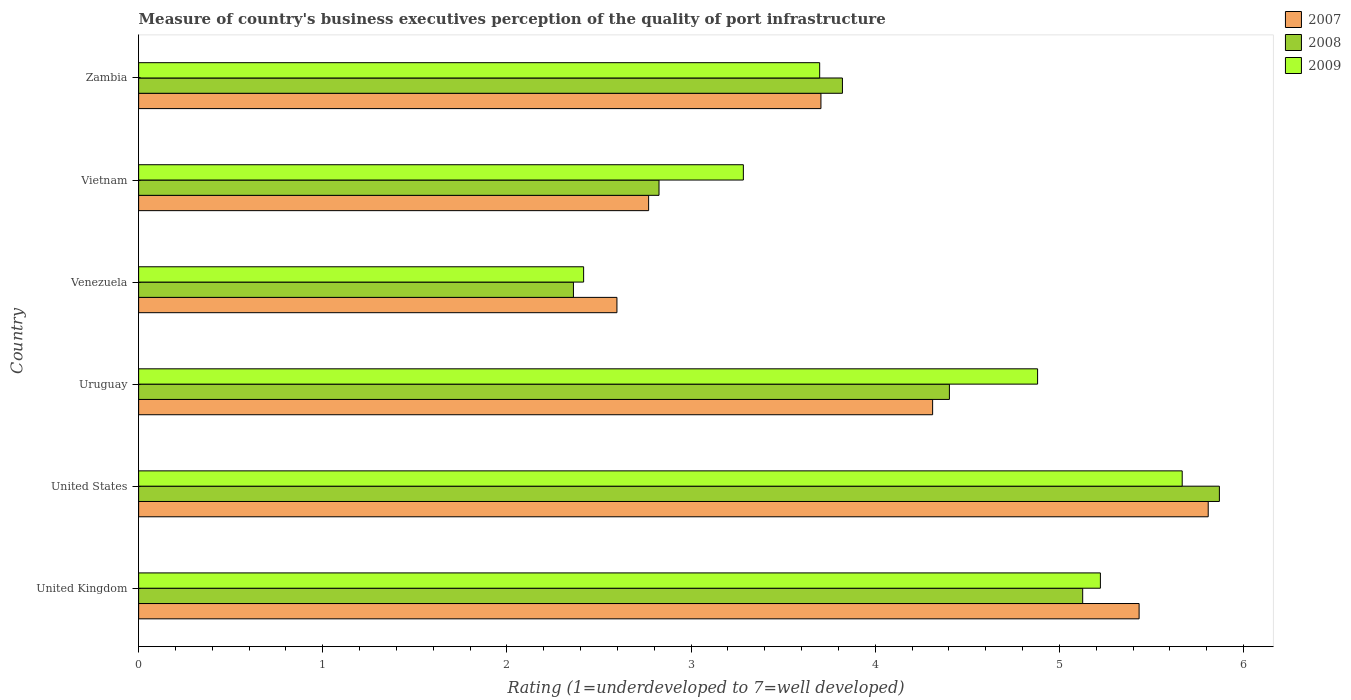How many different coloured bars are there?
Ensure brevity in your answer.  3. How many groups of bars are there?
Give a very brief answer. 6. Are the number of bars on each tick of the Y-axis equal?
Keep it short and to the point. Yes. How many bars are there on the 3rd tick from the top?
Provide a short and direct response. 3. What is the label of the 1st group of bars from the top?
Make the answer very short. Zambia. What is the ratings of the quality of port infrastructure in 2009 in Venezuela?
Offer a very short reply. 2.42. Across all countries, what is the maximum ratings of the quality of port infrastructure in 2008?
Provide a short and direct response. 5.87. Across all countries, what is the minimum ratings of the quality of port infrastructure in 2007?
Keep it short and to the point. 2.6. In which country was the ratings of the quality of port infrastructure in 2008 minimum?
Give a very brief answer. Venezuela. What is the total ratings of the quality of port infrastructure in 2007 in the graph?
Your answer should be compact. 24.62. What is the difference between the ratings of the quality of port infrastructure in 2007 in United States and that in Vietnam?
Offer a terse response. 3.04. What is the difference between the ratings of the quality of port infrastructure in 2007 in Vietnam and the ratings of the quality of port infrastructure in 2008 in United States?
Keep it short and to the point. -3.1. What is the average ratings of the quality of port infrastructure in 2008 per country?
Your answer should be compact. 4.07. What is the difference between the ratings of the quality of port infrastructure in 2008 and ratings of the quality of port infrastructure in 2007 in Zambia?
Your answer should be very brief. 0.12. In how many countries, is the ratings of the quality of port infrastructure in 2009 greater than 3.6 ?
Provide a succinct answer. 4. What is the ratio of the ratings of the quality of port infrastructure in 2009 in United Kingdom to that in Vietnam?
Your answer should be very brief. 1.59. Is the difference between the ratings of the quality of port infrastructure in 2008 in United Kingdom and United States greater than the difference between the ratings of the quality of port infrastructure in 2007 in United Kingdom and United States?
Offer a terse response. No. What is the difference between the highest and the second highest ratings of the quality of port infrastructure in 2008?
Your answer should be compact. 0.74. What is the difference between the highest and the lowest ratings of the quality of port infrastructure in 2008?
Your answer should be compact. 3.51. In how many countries, is the ratings of the quality of port infrastructure in 2008 greater than the average ratings of the quality of port infrastructure in 2008 taken over all countries?
Keep it short and to the point. 3. How many bars are there?
Make the answer very short. 18. Are all the bars in the graph horizontal?
Keep it short and to the point. Yes. Are the values on the major ticks of X-axis written in scientific E-notation?
Offer a very short reply. No. Does the graph contain any zero values?
Make the answer very short. No. Where does the legend appear in the graph?
Offer a very short reply. Top right. What is the title of the graph?
Provide a succinct answer. Measure of country's business executives perception of the quality of port infrastructure. Does "1961" appear as one of the legend labels in the graph?
Your answer should be very brief. No. What is the label or title of the X-axis?
Make the answer very short. Rating (1=underdeveloped to 7=well developed). What is the label or title of the Y-axis?
Give a very brief answer. Country. What is the Rating (1=underdeveloped to 7=well developed) in 2007 in United Kingdom?
Your answer should be very brief. 5.43. What is the Rating (1=underdeveloped to 7=well developed) of 2008 in United Kingdom?
Make the answer very short. 5.13. What is the Rating (1=underdeveloped to 7=well developed) of 2009 in United Kingdom?
Ensure brevity in your answer.  5.22. What is the Rating (1=underdeveloped to 7=well developed) in 2007 in United States?
Keep it short and to the point. 5.81. What is the Rating (1=underdeveloped to 7=well developed) of 2008 in United States?
Your response must be concise. 5.87. What is the Rating (1=underdeveloped to 7=well developed) in 2009 in United States?
Ensure brevity in your answer.  5.67. What is the Rating (1=underdeveloped to 7=well developed) in 2007 in Uruguay?
Your answer should be compact. 4.31. What is the Rating (1=underdeveloped to 7=well developed) of 2008 in Uruguay?
Provide a short and direct response. 4.4. What is the Rating (1=underdeveloped to 7=well developed) in 2009 in Uruguay?
Keep it short and to the point. 4.88. What is the Rating (1=underdeveloped to 7=well developed) of 2007 in Venezuela?
Offer a very short reply. 2.6. What is the Rating (1=underdeveloped to 7=well developed) of 2008 in Venezuela?
Ensure brevity in your answer.  2.36. What is the Rating (1=underdeveloped to 7=well developed) in 2009 in Venezuela?
Give a very brief answer. 2.42. What is the Rating (1=underdeveloped to 7=well developed) of 2007 in Vietnam?
Offer a very short reply. 2.77. What is the Rating (1=underdeveloped to 7=well developed) of 2008 in Vietnam?
Keep it short and to the point. 2.83. What is the Rating (1=underdeveloped to 7=well developed) in 2009 in Vietnam?
Provide a short and direct response. 3.28. What is the Rating (1=underdeveloped to 7=well developed) in 2007 in Zambia?
Keep it short and to the point. 3.7. What is the Rating (1=underdeveloped to 7=well developed) in 2008 in Zambia?
Offer a very short reply. 3.82. What is the Rating (1=underdeveloped to 7=well developed) of 2009 in Zambia?
Provide a short and direct response. 3.7. Across all countries, what is the maximum Rating (1=underdeveloped to 7=well developed) of 2007?
Provide a succinct answer. 5.81. Across all countries, what is the maximum Rating (1=underdeveloped to 7=well developed) of 2008?
Ensure brevity in your answer.  5.87. Across all countries, what is the maximum Rating (1=underdeveloped to 7=well developed) in 2009?
Your response must be concise. 5.67. Across all countries, what is the minimum Rating (1=underdeveloped to 7=well developed) of 2007?
Provide a short and direct response. 2.6. Across all countries, what is the minimum Rating (1=underdeveloped to 7=well developed) in 2008?
Your answer should be compact. 2.36. Across all countries, what is the minimum Rating (1=underdeveloped to 7=well developed) of 2009?
Give a very brief answer. 2.42. What is the total Rating (1=underdeveloped to 7=well developed) in 2007 in the graph?
Provide a succinct answer. 24.62. What is the total Rating (1=underdeveloped to 7=well developed) in 2008 in the graph?
Your answer should be compact. 24.41. What is the total Rating (1=underdeveloped to 7=well developed) in 2009 in the graph?
Offer a very short reply. 25.17. What is the difference between the Rating (1=underdeveloped to 7=well developed) in 2007 in United Kingdom and that in United States?
Your response must be concise. -0.38. What is the difference between the Rating (1=underdeveloped to 7=well developed) in 2008 in United Kingdom and that in United States?
Your response must be concise. -0.74. What is the difference between the Rating (1=underdeveloped to 7=well developed) of 2009 in United Kingdom and that in United States?
Provide a short and direct response. -0.44. What is the difference between the Rating (1=underdeveloped to 7=well developed) in 2007 in United Kingdom and that in Uruguay?
Make the answer very short. 1.12. What is the difference between the Rating (1=underdeveloped to 7=well developed) of 2008 in United Kingdom and that in Uruguay?
Make the answer very short. 0.72. What is the difference between the Rating (1=underdeveloped to 7=well developed) of 2009 in United Kingdom and that in Uruguay?
Make the answer very short. 0.34. What is the difference between the Rating (1=underdeveloped to 7=well developed) in 2007 in United Kingdom and that in Venezuela?
Your answer should be compact. 2.84. What is the difference between the Rating (1=underdeveloped to 7=well developed) of 2008 in United Kingdom and that in Venezuela?
Your answer should be compact. 2.77. What is the difference between the Rating (1=underdeveloped to 7=well developed) of 2009 in United Kingdom and that in Venezuela?
Offer a very short reply. 2.81. What is the difference between the Rating (1=underdeveloped to 7=well developed) in 2007 in United Kingdom and that in Vietnam?
Provide a short and direct response. 2.66. What is the difference between the Rating (1=underdeveloped to 7=well developed) in 2008 in United Kingdom and that in Vietnam?
Give a very brief answer. 2.3. What is the difference between the Rating (1=underdeveloped to 7=well developed) of 2009 in United Kingdom and that in Vietnam?
Your response must be concise. 1.94. What is the difference between the Rating (1=underdeveloped to 7=well developed) of 2007 in United Kingdom and that in Zambia?
Offer a very short reply. 1.73. What is the difference between the Rating (1=underdeveloped to 7=well developed) of 2008 in United Kingdom and that in Zambia?
Your answer should be compact. 1.3. What is the difference between the Rating (1=underdeveloped to 7=well developed) in 2009 in United Kingdom and that in Zambia?
Make the answer very short. 1.52. What is the difference between the Rating (1=underdeveloped to 7=well developed) in 2007 in United States and that in Uruguay?
Provide a short and direct response. 1.5. What is the difference between the Rating (1=underdeveloped to 7=well developed) in 2008 in United States and that in Uruguay?
Offer a terse response. 1.47. What is the difference between the Rating (1=underdeveloped to 7=well developed) in 2009 in United States and that in Uruguay?
Make the answer very short. 0.79. What is the difference between the Rating (1=underdeveloped to 7=well developed) in 2007 in United States and that in Venezuela?
Keep it short and to the point. 3.21. What is the difference between the Rating (1=underdeveloped to 7=well developed) of 2008 in United States and that in Venezuela?
Offer a terse response. 3.51. What is the difference between the Rating (1=underdeveloped to 7=well developed) in 2009 in United States and that in Venezuela?
Your answer should be compact. 3.25. What is the difference between the Rating (1=underdeveloped to 7=well developed) of 2007 in United States and that in Vietnam?
Keep it short and to the point. 3.04. What is the difference between the Rating (1=underdeveloped to 7=well developed) in 2008 in United States and that in Vietnam?
Offer a terse response. 3.04. What is the difference between the Rating (1=underdeveloped to 7=well developed) in 2009 in United States and that in Vietnam?
Your answer should be very brief. 2.38. What is the difference between the Rating (1=underdeveloped to 7=well developed) in 2007 in United States and that in Zambia?
Keep it short and to the point. 2.1. What is the difference between the Rating (1=underdeveloped to 7=well developed) in 2008 in United States and that in Zambia?
Make the answer very short. 2.05. What is the difference between the Rating (1=underdeveloped to 7=well developed) of 2009 in United States and that in Zambia?
Your response must be concise. 1.97. What is the difference between the Rating (1=underdeveloped to 7=well developed) of 2007 in Uruguay and that in Venezuela?
Offer a very short reply. 1.71. What is the difference between the Rating (1=underdeveloped to 7=well developed) of 2008 in Uruguay and that in Venezuela?
Ensure brevity in your answer.  2.04. What is the difference between the Rating (1=underdeveloped to 7=well developed) of 2009 in Uruguay and that in Venezuela?
Your answer should be compact. 2.46. What is the difference between the Rating (1=underdeveloped to 7=well developed) in 2007 in Uruguay and that in Vietnam?
Keep it short and to the point. 1.54. What is the difference between the Rating (1=underdeveloped to 7=well developed) in 2008 in Uruguay and that in Vietnam?
Offer a terse response. 1.58. What is the difference between the Rating (1=underdeveloped to 7=well developed) of 2009 in Uruguay and that in Vietnam?
Your response must be concise. 1.6. What is the difference between the Rating (1=underdeveloped to 7=well developed) in 2007 in Uruguay and that in Zambia?
Your response must be concise. 0.61. What is the difference between the Rating (1=underdeveloped to 7=well developed) of 2008 in Uruguay and that in Zambia?
Give a very brief answer. 0.58. What is the difference between the Rating (1=underdeveloped to 7=well developed) of 2009 in Uruguay and that in Zambia?
Offer a terse response. 1.18. What is the difference between the Rating (1=underdeveloped to 7=well developed) in 2007 in Venezuela and that in Vietnam?
Offer a very short reply. -0.17. What is the difference between the Rating (1=underdeveloped to 7=well developed) in 2008 in Venezuela and that in Vietnam?
Provide a succinct answer. -0.46. What is the difference between the Rating (1=underdeveloped to 7=well developed) of 2009 in Venezuela and that in Vietnam?
Your answer should be compact. -0.87. What is the difference between the Rating (1=underdeveloped to 7=well developed) in 2007 in Venezuela and that in Zambia?
Offer a very short reply. -1.11. What is the difference between the Rating (1=underdeveloped to 7=well developed) of 2008 in Venezuela and that in Zambia?
Your answer should be compact. -1.46. What is the difference between the Rating (1=underdeveloped to 7=well developed) in 2009 in Venezuela and that in Zambia?
Offer a very short reply. -1.28. What is the difference between the Rating (1=underdeveloped to 7=well developed) in 2007 in Vietnam and that in Zambia?
Give a very brief answer. -0.94. What is the difference between the Rating (1=underdeveloped to 7=well developed) in 2008 in Vietnam and that in Zambia?
Make the answer very short. -1. What is the difference between the Rating (1=underdeveloped to 7=well developed) of 2009 in Vietnam and that in Zambia?
Offer a very short reply. -0.41. What is the difference between the Rating (1=underdeveloped to 7=well developed) in 2007 in United Kingdom and the Rating (1=underdeveloped to 7=well developed) in 2008 in United States?
Provide a short and direct response. -0.44. What is the difference between the Rating (1=underdeveloped to 7=well developed) in 2007 in United Kingdom and the Rating (1=underdeveloped to 7=well developed) in 2009 in United States?
Ensure brevity in your answer.  -0.23. What is the difference between the Rating (1=underdeveloped to 7=well developed) in 2008 in United Kingdom and the Rating (1=underdeveloped to 7=well developed) in 2009 in United States?
Keep it short and to the point. -0.54. What is the difference between the Rating (1=underdeveloped to 7=well developed) of 2007 in United Kingdom and the Rating (1=underdeveloped to 7=well developed) of 2008 in Uruguay?
Make the answer very short. 1.03. What is the difference between the Rating (1=underdeveloped to 7=well developed) in 2007 in United Kingdom and the Rating (1=underdeveloped to 7=well developed) in 2009 in Uruguay?
Provide a short and direct response. 0.55. What is the difference between the Rating (1=underdeveloped to 7=well developed) of 2008 in United Kingdom and the Rating (1=underdeveloped to 7=well developed) of 2009 in Uruguay?
Your answer should be compact. 0.24. What is the difference between the Rating (1=underdeveloped to 7=well developed) in 2007 in United Kingdom and the Rating (1=underdeveloped to 7=well developed) in 2008 in Venezuela?
Give a very brief answer. 3.07. What is the difference between the Rating (1=underdeveloped to 7=well developed) of 2007 in United Kingdom and the Rating (1=underdeveloped to 7=well developed) of 2009 in Venezuela?
Your answer should be very brief. 3.02. What is the difference between the Rating (1=underdeveloped to 7=well developed) in 2008 in United Kingdom and the Rating (1=underdeveloped to 7=well developed) in 2009 in Venezuela?
Give a very brief answer. 2.71. What is the difference between the Rating (1=underdeveloped to 7=well developed) in 2007 in United Kingdom and the Rating (1=underdeveloped to 7=well developed) in 2008 in Vietnam?
Offer a terse response. 2.61. What is the difference between the Rating (1=underdeveloped to 7=well developed) of 2007 in United Kingdom and the Rating (1=underdeveloped to 7=well developed) of 2009 in Vietnam?
Provide a succinct answer. 2.15. What is the difference between the Rating (1=underdeveloped to 7=well developed) of 2008 in United Kingdom and the Rating (1=underdeveloped to 7=well developed) of 2009 in Vietnam?
Offer a very short reply. 1.84. What is the difference between the Rating (1=underdeveloped to 7=well developed) of 2007 in United Kingdom and the Rating (1=underdeveloped to 7=well developed) of 2008 in Zambia?
Your answer should be very brief. 1.61. What is the difference between the Rating (1=underdeveloped to 7=well developed) of 2007 in United Kingdom and the Rating (1=underdeveloped to 7=well developed) of 2009 in Zambia?
Your answer should be very brief. 1.73. What is the difference between the Rating (1=underdeveloped to 7=well developed) in 2008 in United Kingdom and the Rating (1=underdeveloped to 7=well developed) in 2009 in Zambia?
Give a very brief answer. 1.43. What is the difference between the Rating (1=underdeveloped to 7=well developed) in 2007 in United States and the Rating (1=underdeveloped to 7=well developed) in 2008 in Uruguay?
Provide a short and direct response. 1.41. What is the difference between the Rating (1=underdeveloped to 7=well developed) of 2007 in United States and the Rating (1=underdeveloped to 7=well developed) of 2009 in Uruguay?
Provide a succinct answer. 0.93. What is the difference between the Rating (1=underdeveloped to 7=well developed) of 2008 in United States and the Rating (1=underdeveloped to 7=well developed) of 2009 in Uruguay?
Provide a short and direct response. 0.99. What is the difference between the Rating (1=underdeveloped to 7=well developed) of 2007 in United States and the Rating (1=underdeveloped to 7=well developed) of 2008 in Venezuela?
Make the answer very short. 3.45. What is the difference between the Rating (1=underdeveloped to 7=well developed) of 2007 in United States and the Rating (1=underdeveloped to 7=well developed) of 2009 in Venezuela?
Provide a short and direct response. 3.39. What is the difference between the Rating (1=underdeveloped to 7=well developed) in 2008 in United States and the Rating (1=underdeveloped to 7=well developed) in 2009 in Venezuela?
Your answer should be compact. 3.45. What is the difference between the Rating (1=underdeveloped to 7=well developed) of 2007 in United States and the Rating (1=underdeveloped to 7=well developed) of 2008 in Vietnam?
Provide a succinct answer. 2.98. What is the difference between the Rating (1=underdeveloped to 7=well developed) of 2007 in United States and the Rating (1=underdeveloped to 7=well developed) of 2009 in Vietnam?
Your answer should be compact. 2.52. What is the difference between the Rating (1=underdeveloped to 7=well developed) of 2008 in United States and the Rating (1=underdeveloped to 7=well developed) of 2009 in Vietnam?
Offer a terse response. 2.58. What is the difference between the Rating (1=underdeveloped to 7=well developed) in 2007 in United States and the Rating (1=underdeveloped to 7=well developed) in 2008 in Zambia?
Provide a succinct answer. 1.99. What is the difference between the Rating (1=underdeveloped to 7=well developed) of 2007 in United States and the Rating (1=underdeveloped to 7=well developed) of 2009 in Zambia?
Your response must be concise. 2.11. What is the difference between the Rating (1=underdeveloped to 7=well developed) of 2008 in United States and the Rating (1=underdeveloped to 7=well developed) of 2009 in Zambia?
Your response must be concise. 2.17. What is the difference between the Rating (1=underdeveloped to 7=well developed) of 2007 in Uruguay and the Rating (1=underdeveloped to 7=well developed) of 2008 in Venezuela?
Your answer should be very brief. 1.95. What is the difference between the Rating (1=underdeveloped to 7=well developed) in 2007 in Uruguay and the Rating (1=underdeveloped to 7=well developed) in 2009 in Venezuela?
Make the answer very short. 1.9. What is the difference between the Rating (1=underdeveloped to 7=well developed) of 2008 in Uruguay and the Rating (1=underdeveloped to 7=well developed) of 2009 in Venezuela?
Your response must be concise. 1.99. What is the difference between the Rating (1=underdeveloped to 7=well developed) of 2007 in Uruguay and the Rating (1=underdeveloped to 7=well developed) of 2008 in Vietnam?
Provide a short and direct response. 1.49. What is the difference between the Rating (1=underdeveloped to 7=well developed) in 2007 in Uruguay and the Rating (1=underdeveloped to 7=well developed) in 2009 in Vietnam?
Give a very brief answer. 1.03. What is the difference between the Rating (1=underdeveloped to 7=well developed) of 2008 in Uruguay and the Rating (1=underdeveloped to 7=well developed) of 2009 in Vietnam?
Offer a terse response. 1.12. What is the difference between the Rating (1=underdeveloped to 7=well developed) of 2007 in Uruguay and the Rating (1=underdeveloped to 7=well developed) of 2008 in Zambia?
Ensure brevity in your answer.  0.49. What is the difference between the Rating (1=underdeveloped to 7=well developed) of 2007 in Uruguay and the Rating (1=underdeveloped to 7=well developed) of 2009 in Zambia?
Offer a terse response. 0.61. What is the difference between the Rating (1=underdeveloped to 7=well developed) of 2008 in Uruguay and the Rating (1=underdeveloped to 7=well developed) of 2009 in Zambia?
Give a very brief answer. 0.7. What is the difference between the Rating (1=underdeveloped to 7=well developed) of 2007 in Venezuela and the Rating (1=underdeveloped to 7=well developed) of 2008 in Vietnam?
Offer a very short reply. -0.23. What is the difference between the Rating (1=underdeveloped to 7=well developed) of 2007 in Venezuela and the Rating (1=underdeveloped to 7=well developed) of 2009 in Vietnam?
Offer a terse response. -0.69. What is the difference between the Rating (1=underdeveloped to 7=well developed) of 2008 in Venezuela and the Rating (1=underdeveloped to 7=well developed) of 2009 in Vietnam?
Keep it short and to the point. -0.92. What is the difference between the Rating (1=underdeveloped to 7=well developed) in 2007 in Venezuela and the Rating (1=underdeveloped to 7=well developed) in 2008 in Zambia?
Your response must be concise. -1.22. What is the difference between the Rating (1=underdeveloped to 7=well developed) of 2007 in Venezuela and the Rating (1=underdeveloped to 7=well developed) of 2009 in Zambia?
Give a very brief answer. -1.1. What is the difference between the Rating (1=underdeveloped to 7=well developed) of 2008 in Venezuela and the Rating (1=underdeveloped to 7=well developed) of 2009 in Zambia?
Offer a terse response. -1.34. What is the difference between the Rating (1=underdeveloped to 7=well developed) of 2007 in Vietnam and the Rating (1=underdeveloped to 7=well developed) of 2008 in Zambia?
Keep it short and to the point. -1.05. What is the difference between the Rating (1=underdeveloped to 7=well developed) of 2007 in Vietnam and the Rating (1=underdeveloped to 7=well developed) of 2009 in Zambia?
Your response must be concise. -0.93. What is the difference between the Rating (1=underdeveloped to 7=well developed) in 2008 in Vietnam and the Rating (1=underdeveloped to 7=well developed) in 2009 in Zambia?
Provide a succinct answer. -0.87. What is the average Rating (1=underdeveloped to 7=well developed) of 2007 per country?
Give a very brief answer. 4.1. What is the average Rating (1=underdeveloped to 7=well developed) of 2008 per country?
Your answer should be very brief. 4.07. What is the average Rating (1=underdeveloped to 7=well developed) of 2009 per country?
Make the answer very short. 4.19. What is the difference between the Rating (1=underdeveloped to 7=well developed) of 2007 and Rating (1=underdeveloped to 7=well developed) of 2008 in United Kingdom?
Make the answer very short. 0.31. What is the difference between the Rating (1=underdeveloped to 7=well developed) in 2007 and Rating (1=underdeveloped to 7=well developed) in 2009 in United Kingdom?
Give a very brief answer. 0.21. What is the difference between the Rating (1=underdeveloped to 7=well developed) of 2008 and Rating (1=underdeveloped to 7=well developed) of 2009 in United Kingdom?
Offer a terse response. -0.1. What is the difference between the Rating (1=underdeveloped to 7=well developed) of 2007 and Rating (1=underdeveloped to 7=well developed) of 2008 in United States?
Offer a very short reply. -0.06. What is the difference between the Rating (1=underdeveloped to 7=well developed) in 2007 and Rating (1=underdeveloped to 7=well developed) in 2009 in United States?
Your response must be concise. 0.14. What is the difference between the Rating (1=underdeveloped to 7=well developed) in 2008 and Rating (1=underdeveloped to 7=well developed) in 2009 in United States?
Offer a terse response. 0.2. What is the difference between the Rating (1=underdeveloped to 7=well developed) in 2007 and Rating (1=underdeveloped to 7=well developed) in 2008 in Uruguay?
Your response must be concise. -0.09. What is the difference between the Rating (1=underdeveloped to 7=well developed) in 2007 and Rating (1=underdeveloped to 7=well developed) in 2009 in Uruguay?
Make the answer very short. -0.57. What is the difference between the Rating (1=underdeveloped to 7=well developed) of 2008 and Rating (1=underdeveloped to 7=well developed) of 2009 in Uruguay?
Ensure brevity in your answer.  -0.48. What is the difference between the Rating (1=underdeveloped to 7=well developed) in 2007 and Rating (1=underdeveloped to 7=well developed) in 2008 in Venezuela?
Keep it short and to the point. 0.24. What is the difference between the Rating (1=underdeveloped to 7=well developed) in 2007 and Rating (1=underdeveloped to 7=well developed) in 2009 in Venezuela?
Your response must be concise. 0.18. What is the difference between the Rating (1=underdeveloped to 7=well developed) in 2008 and Rating (1=underdeveloped to 7=well developed) in 2009 in Venezuela?
Ensure brevity in your answer.  -0.06. What is the difference between the Rating (1=underdeveloped to 7=well developed) in 2007 and Rating (1=underdeveloped to 7=well developed) in 2008 in Vietnam?
Make the answer very short. -0.06. What is the difference between the Rating (1=underdeveloped to 7=well developed) of 2007 and Rating (1=underdeveloped to 7=well developed) of 2009 in Vietnam?
Ensure brevity in your answer.  -0.51. What is the difference between the Rating (1=underdeveloped to 7=well developed) in 2008 and Rating (1=underdeveloped to 7=well developed) in 2009 in Vietnam?
Your answer should be very brief. -0.46. What is the difference between the Rating (1=underdeveloped to 7=well developed) of 2007 and Rating (1=underdeveloped to 7=well developed) of 2008 in Zambia?
Your answer should be very brief. -0.12. What is the difference between the Rating (1=underdeveloped to 7=well developed) in 2007 and Rating (1=underdeveloped to 7=well developed) in 2009 in Zambia?
Provide a succinct answer. 0.01. What is the difference between the Rating (1=underdeveloped to 7=well developed) of 2008 and Rating (1=underdeveloped to 7=well developed) of 2009 in Zambia?
Ensure brevity in your answer.  0.12. What is the ratio of the Rating (1=underdeveloped to 7=well developed) in 2007 in United Kingdom to that in United States?
Offer a very short reply. 0.94. What is the ratio of the Rating (1=underdeveloped to 7=well developed) in 2008 in United Kingdom to that in United States?
Your answer should be very brief. 0.87. What is the ratio of the Rating (1=underdeveloped to 7=well developed) in 2009 in United Kingdom to that in United States?
Provide a succinct answer. 0.92. What is the ratio of the Rating (1=underdeveloped to 7=well developed) of 2007 in United Kingdom to that in Uruguay?
Your response must be concise. 1.26. What is the ratio of the Rating (1=underdeveloped to 7=well developed) in 2008 in United Kingdom to that in Uruguay?
Ensure brevity in your answer.  1.16. What is the ratio of the Rating (1=underdeveloped to 7=well developed) of 2009 in United Kingdom to that in Uruguay?
Provide a succinct answer. 1.07. What is the ratio of the Rating (1=underdeveloped to 7=well developed) in 2007 in United Kingdom to that in Venezuela?
Provide a short and direct response. 2.09. What is the ratio of the Rating (1=underdeveloped to 7=well developed) in 2008 in United Kingdom to that in Venezuela?
Your answer should be compact. 2.17. What is the ratio of the Rating (1=underdeveloped to 7=well developed) of 2009 in United Kingdom to that in Venezuela?
Your answer should be compact. 2.16. What is the ratio of the Rating (1=underdeveloped to 7=well developed) of 2007 in United Kingdom to that in Vietnam?
Offer a very short reply. 1.96. What is the ratio of the Rating (1=underdeveloped to 7=well developed) in 2008 in United Kingdom to that in Vietnam?
Make the answer very short. 1.81. What is the ratio of the Rating (1=underdeveloped to 7=well developed) in 2009 in United Kingdom to that in Vietnam?
Provide a short and direct response. 1.59. What is the ratio of the Rating (1=underdeveloped to 7=well developed) in 2007 in United Kingdom to that in Zambia?
Provide a succinct answer. 1.47. What is the ratio of the Rating (1=underdeveloped to 7=well developed) of 2008 in United Kingdom to that in Zambia?
Offer a terse response. 1.34. What is the ratio of the Rating (1=underdeveloped to 7=well developed) in 2009 in United Kingdom to that in Zambia?
Provide a succinct answer. 1.41. What is the ratio of the Rating (1=underdeveloped to 7=well developed) of 2007 in United States to that in Uruguay?
Make the answer very short. 1.35. What is the ratio of the Rating (1=underdeveloped to 7=well developed) in 2008 in United States to that in Uruguay?
Ensure brevity in your answer.  1.33. What is the ratio of the Rating (1=underdeveloped to 7=well developed) of 2009 in United States to that in Uruguay?
Your answer should be compact. 1.16. What is the ratio of the Rating (1=underdeveloped to 7=well developed) in 2007 in United States to that in Venezuela?
Give a very brief answer. 2.24. What is the ratio of the Rating (1=underdeveloped to 7=well developed) in 2008 in United States to that in Venezuela?
Offer a very short reply. 2.49. What is the ratio of the Rating (1=underdeveloped to 7=well developed) in 2009 in United States to that in Venezuela?
Give a very brief answer. 2.35. What is the ratio of the Rating (1=underdeveloped to 7=well developed) of 2007 in United States to that in Vietnam?
Give a very brief answer. 2.1. What is the ratio of the Rating (1=underdeveloped to 7=well developed) of 2008 in United States to that in Vietnam?
Keep it short and to the point. 2.08. What is the ratio of the Rating (1=underdeveloped to 7=well developed) of 2009 in United States to that in Vietnam?
Your answer should be very brief. 1.73. What is the ratio of the Rating (1=underdeveloped to 7=well developed) in 2007 in United States to that in Zambia?
Your answer should be very brief. 1.57. What is the ratio of the Rating (1=underdeveloped to 7=well developed) of 2008 in United States to that in Zambia?
Your response must be concise. 1.54. What is the ratio of the Rating (1=underdeveloped to 7=well developed) of 2009 in United States to that in Zambia?
Provide a short and direct response. 1.53. What is the ratio of the Rating (1=underdeveloped to 7=well developed) of 2007 in Uruguay to that in Venezuela?
Offer a terse response. 1.66. What is the ratio of the Rating (1=underdeveloped to 7=well developed) in 2008 in Uruguay to that in Venezuela?
Offer a terse response. 1.86. What is the ratio of the Rating (1=underdeveloped to 7=well developed) in 2009 in Uruguay to that in Venezuela?
Provide a succinct answer. 2.02. What is the ratio of the Rating (1=underdeveloped to 7=well developed) in 2007 in Uruguay to that in Vietnam?
Offer a terse response. 1.56. What is the ratio of the Rating (1=underdeveloped to 7=well developed) in 2008 in Uruguay to that in Vietnam?
Make the answer very short. 1.56. What is the ratio of the Rating (1=underdeveloped to 7=well developed) of 2009 in Uruguay to that in Vietnam?
Your answer should be very brief. 1.49. What is the ratio of the Rating (1=underdeveloped to 7=well developed) of 2007 in Uruguay to that in Zambia?
Ensure brevity in your answer.  1.16. What is the ratio of the Rating (1=underdeveloped to 7=well developed) of 2008 in Uruguay to that in Zambia?
Your answer should be very brief. 1.15. What is the ratio of the Rating (1=underdeveloped to 7=well developed) of 2009 in Uruguay to that in Zambia?
Your response must be concise. 1.32. What is the ratio of the Rating (1=underdeveloped to 7=well developed) in 2007 in Venezuela to that in Vietnam?
Make the answer very short. 0.94. What is the ratio of the Rating (1=underdeveloped to 7=well developed) in 2008 in Venezuela to that in Vietnam?
Offer a terse response. 0.84. What is the ratio of the Rating (1=underdeveloped to 7=well developed) of 2009 in Venezuela to that in Vietnam?
Make the answer very short. 0.74. What is the ratio of the Rating (1=underdeveloped to 7=well developed) of 2007 in Venezuela to that in Zambia?
Provide a succinct answer. 0.7. What is the ratio of the Rating (1=underdeveloped to 7=well developed) of 2008 in Venezuela to that in Zambia?
Offer a very short reply. 0.62. What is the ratio of the Rating (1=underdeveloped to 7=well developed) of 2009 in Venezuela to that in Zambia?
Your response must be concise. 0.65. What is the ratio of the Rating (1=underdeveloped to 7=well developed) of 2007 in Vietnam to that in Zambia?
Provide a succinct answer. 0.75. What is the ratio of the Rating (1=underdeveloped to 7=well developed) of 2008 in Vietnam to that in Zambia?
Make the answer very short. 0.74. What is the ratio of the Rating (1=underdeveloped to 7=well developed) in 2009 in Vietnam to that in Zambia?
Provide a short and direct response. 0.89. What is the difference between the highest and the second highest Rating (1=underdeveloped to 7=well developed) in 2007?
Make the answer very short. 0.38. What is the difference between the highest and the second highest Rating (1=underdeveloped to 7=well developed) in 2008?
Make the answer very short. 0.74. What is the difference between the highest and the second highest Rating (1=underdeveloped to 7=well developed) of 2009?
Make the answer very short. 0.44. What is the difference between the highest and the lowest Rating (1=underdeveloped to 7=well developed) of 2007?
Offer a terse response. 3.21. What is the difference between the highest and the lowest Rating (1=underdeveloped to 7=well developed) in 2008?
Keep it short and to the point. 3.51. What is the difference between the highest and the lowest Rating (1=underdeveloped to 7=well developed) in 2009?
Provide a short and direct response. 3.25. 